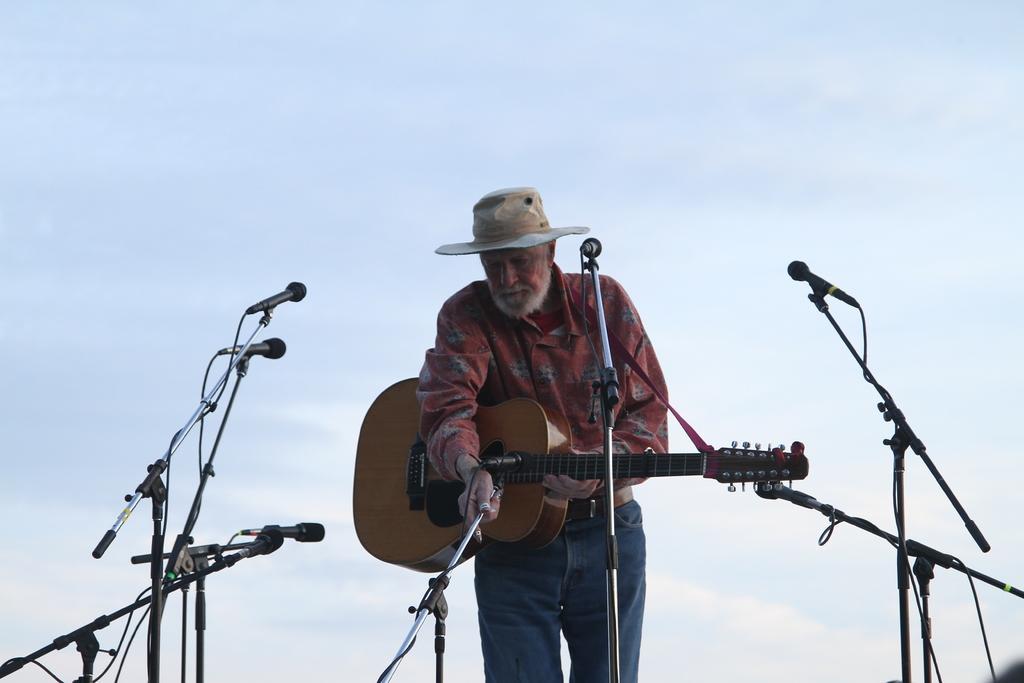Please provide a concise description of this image. In this image I can see a person is standing and holding a guitar. I can also see he is wearing a hat. I can see number of mics around him. 